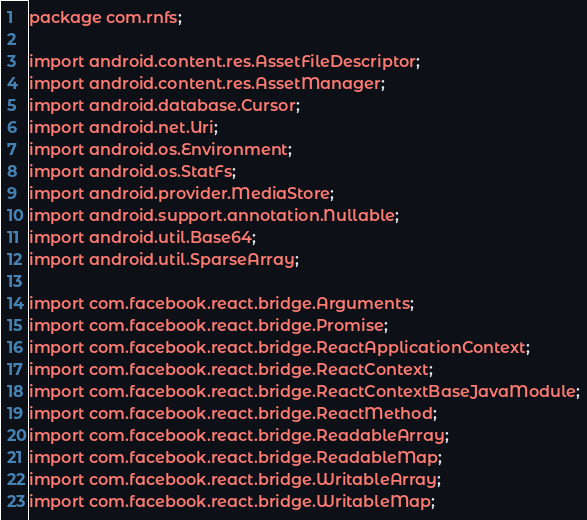<code> <loc_0><loc_0><loc_500><loc_500><_Java_>package com.rnfs;

import android.content.res.AssetFileDescriptor;
import android.content.res.AssetManager;
import android.database.Cursor;
import android.net.Uri;
import android.os.Environment;
import android.os.StatFs;
import android.provider.MediaStore;
import android.support.annotation.Nullable;
import android.util.Base64;
import android.util.SparseArray;

import com.facebook.react.bridge.Arguments;
import com.facebook.react.bridge.Promise;
import com.facebook.react.bridge.ReactApplicationContext;
import com.facebook.react.bridge.ReactContext;
import com.facebook.react.bridge.ReactContextBaseJavaModule;
import com.facebook.react.bridge.ReactMethod;
import com.facebook.react.bridge.ReadableArray;
import com.facebook.react.bridge.ReadableMap;
import com.facebook.react.bridge.WritableArray;
import com.facebook.react.bridge.WritableMap;</code> 